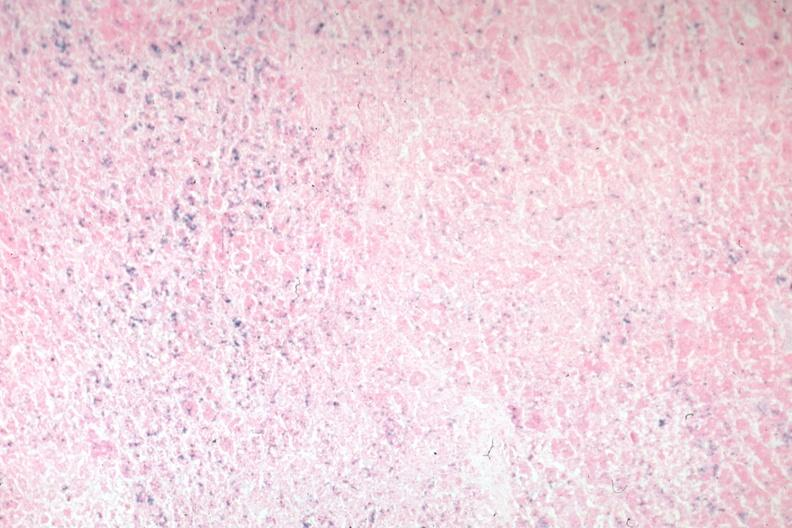does cachexia stain?
Answer the question using a single word or phrase. No 